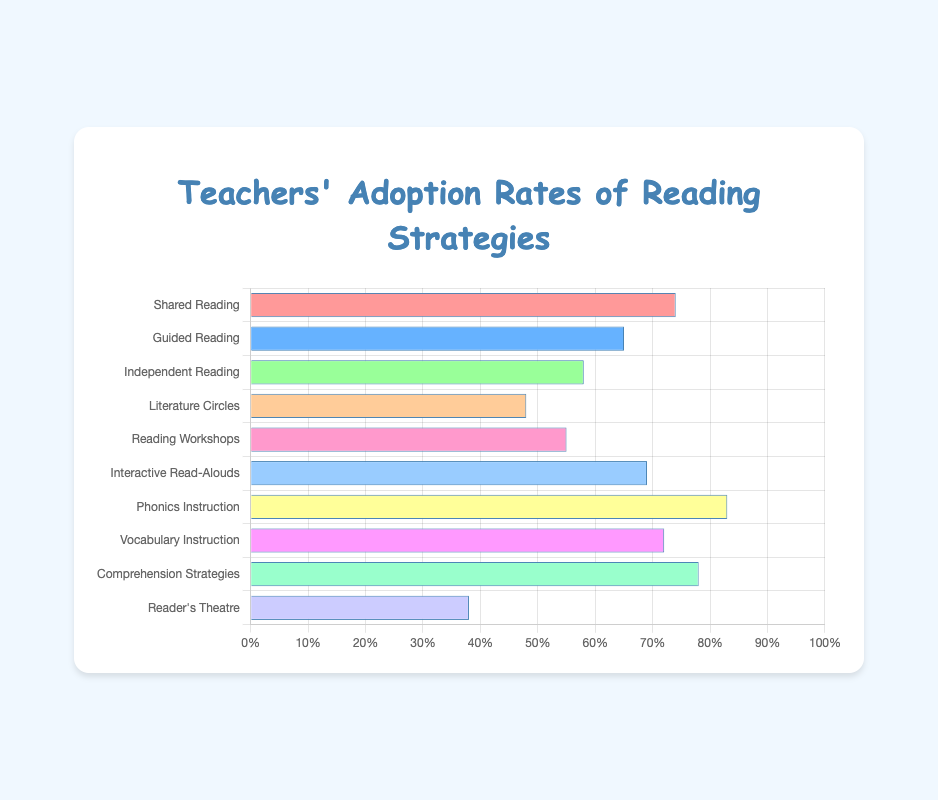Which reading strategy has the highest adoption rate? To find the strategy with the highest adoption rate, look for the longest bar on the horizontal bar chart. The label corresponding to this bar is the strategy with the highest adoption rate.
Answer: Phonics Instruction Which reading strategy has the lowest adoption rate? Look for the shortest bar on the horizontal bar chart. The label corresponding to this bar is the strategy with the lowest adoption rate.
Answer: Reader's Theatre What is the difference in adoption rates between "Shared Reading" and "Guided Reading"? Identify the adoption rates of "Shared Reading" (74%) and "Guided Reading" (65%). Subtract the smaller rate from the larger rate. 74 - 65 = 9
Answer: 9 How much higher is the adoption rate for "Phonics Instruction" compared to "Independent Reading"? Locate the adoption rates for "Phonics Instruction" (83%) and "Independent Reading" (58%). Subtract the "Independent Reading" rate from the "Phonics Instruction" rate. 83 - 58 = 25
Answer: 25 What is the average adoption rate of "Interactive Read-Alouds," "Vocabulary Instruction," and "Comprehension Strategies"? Obtain the adoption rates for "Interactive Read-Alouds" (69%), "Vocabulary Instruction" (72%), and "Comprehension Strategies" (78%). Sum these rates and divide by the number of strategies. (69 + 72 + 78) / 3 = 73
Answer: 73 What color is used for the bar representing "Literature Circles"? Identify the bar labeled "Literature Circles" and note its color.
Answer: Pink What is the sum of adoption rates for all strategies? Sum the adoption rates for all 10 strategies: 74 + 65 + 58 + 48 + 55 + 69 + 83 + 72 + 78 + 38 = 640
Answer: 640 Which strategies have adoption rates above 70%? Identify the strategies with bars extending beyond the 70% mark: "Shared Reading" (74%), "Phonics Instruction" (83%), "Comprehension Strategies" (78%), and "Vocabulary Instruction" (72%).
Answer: Shared Reading, Phonics Instruction, Comprehension Strategies, Vocabulary Instruction Which strategies have adoption rates below 60%? Identify the strategies with bars that do not reach the 60% mark: "Independent Reading" (58%), "Literature Circles" (48%), "Reading Workshops" (55%), and "Reader's Theatre" (38%).
Answer: Independent Reading, Literature Circles, Reading Workshops, Reader's Theatre 